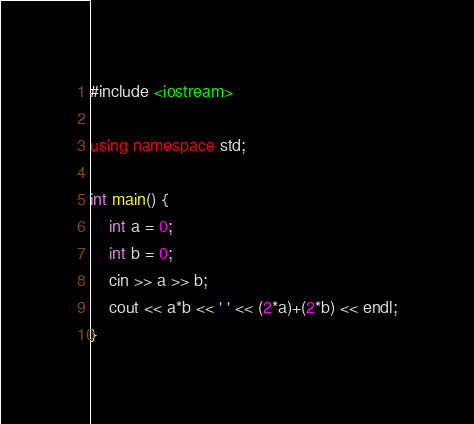<code> <loc_0><loc_0><loc_500><loc_500><_C++_>#include <iostream>

using namespace std;

int main() {
	int a = 0;
	int b = 0;
	cin >> a >> b;
	cout << a*b << ' ' << (2*a)+(2*b) << endl;
}
</code> 